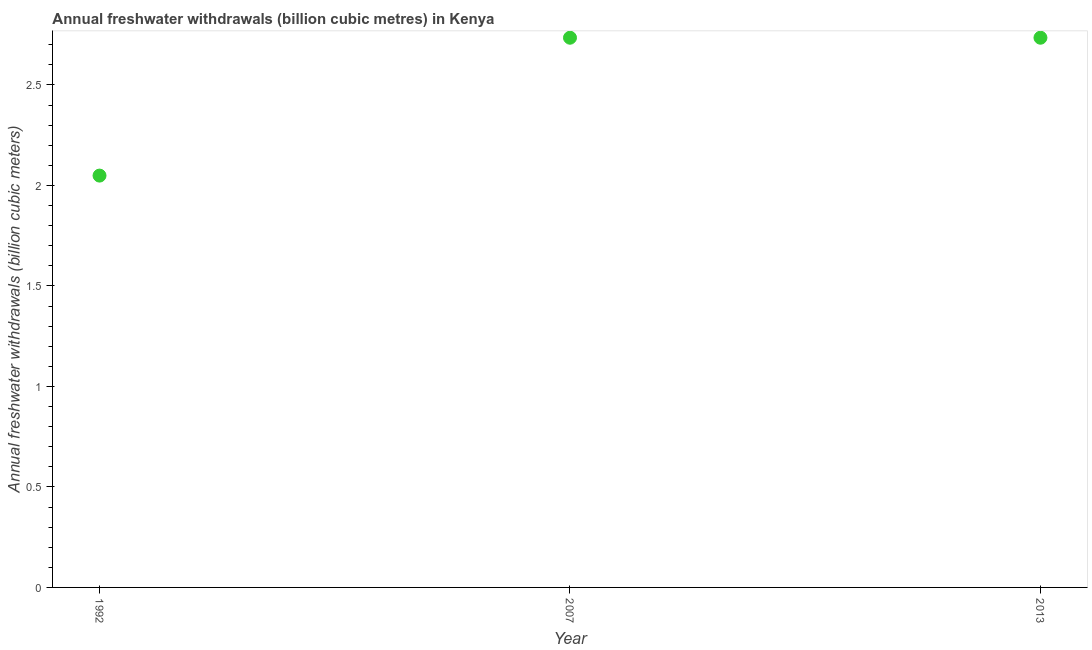What is the annual freshwater withdrawals in 2013?
Provide a short and direct response. 2.73. Across all years, what is the maximum annual freshwater withdrawals?
Your response must be concise. 2.73. Across all years, what is the minimum annual freshwater withdrawals?
Keep it short and to the point. 2.05. In which year was the annual freshwater withdrawals maximum?
Provide a succinct answer. 2007. What is the sum of the annual freshwater withdrawals?
Your answer should be compact. 7.52. What is the difference between the annual freshwater withdrawals in 1992 and 2007?
Give a very brief answer. -0.69. What is the average annual freshwater withdrawals per year?
Your answer should be compact. 2.51. What is the median annual freshwater withdrawals?
Give a very brief answer. 2.73. In how many years, is the annual freshwater withdrawals greater than 1.1 billion cubic meters?
Make the answer very short. 3. What is the ratio of the annual freshwater withdrawals in 1992 to that in 2013?
Make the answer very short. 0.75. Is the annual freshwater withdrawals in 2007 less than that in 2013?
Your response must be concise. No. What is the difference between the highest and the lowest annual freshwater withdrawals?
Your answer should be very brief. 0.69. In how many years, is the annual freshwater withdrawals greater than the average annual freshwater withdrawals taken over all years?
Your response must be concise. 2. How many years are there in the graph?
Your answer should be compact. 3. Does the graph contain any zero values?
Provide a succinct answer. No. What is the title of the graph?
Offer a very short reply. Annual freshwater withdrawals (billion cubic metres) in Kenya. What is the label or title of the Y-axis?
Offer a very short reply. Annual freshwater withdrawals (billion cubic meters). What is the Annual freshwater withdrawals (billion cubic meters) in 1992?
Provide a succinct answer. 2.05. What is the Annual freshwater withdrawals (billion cubic meters) in 2007?
Keep it short and to the point. 2.73. What is the Annual freshwater withdrawals (billion cubic meters) in 2013?
Provide a short and direct response. 2.73. What is the difference between the Annual freshwater withdrawals (billion cubic meters) in 1992 and 2007?
Give a very brief answer. -0.69. What is the difference between the Annual freshwater withdrawals (billion cubic meters) in 1992 and 2013?
Ensure brevity in your answer.  -0.69. What is the difference between the Annual freshwater withdrawals (billion cubic meters) in 2007 and 2013?
Your answer should be compact. 0. What is the ratio of the Annual freshwater withdrawals (billion cubic meters) in 1992 to that in 2007?
Keep it short and to the point. 0.75. What is the ratio of the Annual freshwater withdrawals (billion cubic meters) in 1992 to that in 2013?
Offer a very short reply. 0.75. 